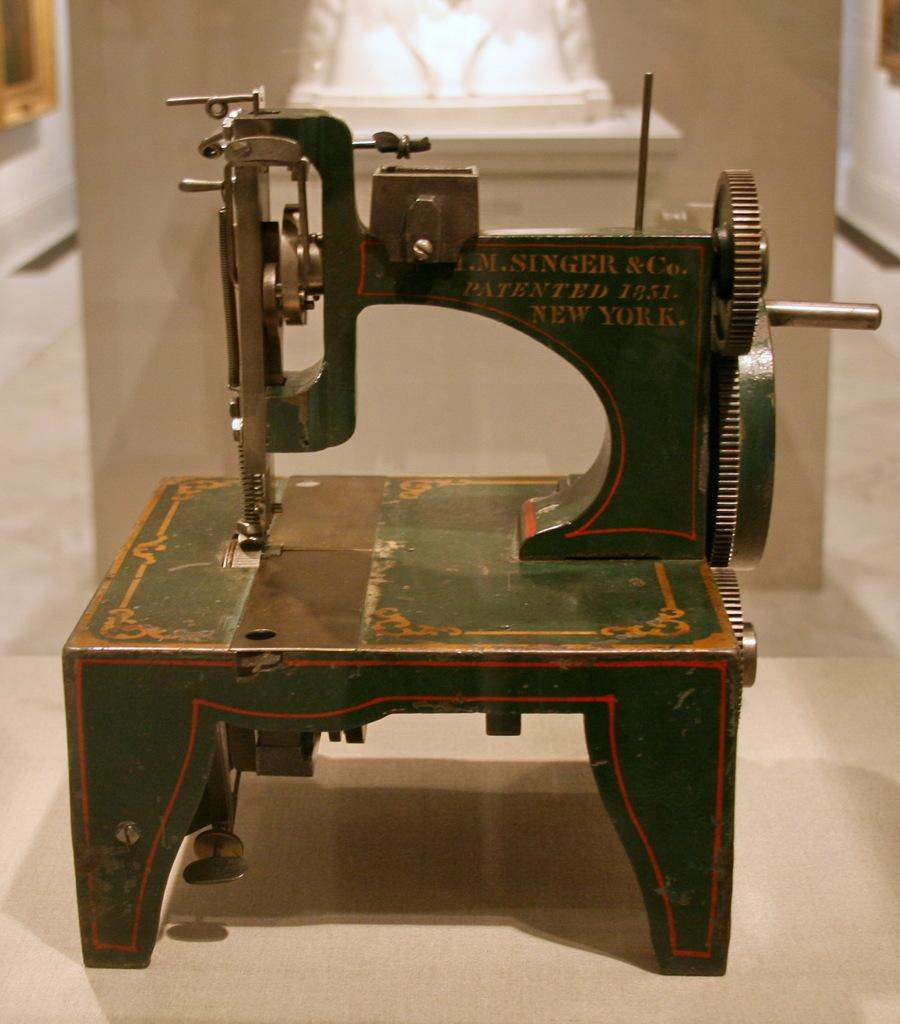What is the main object in the image? There is a tailoring machine in the image. Where is the tailoring machine located? The tailoring machine is placed on a table. What type of plantation can be seen in the background of the image? There is no plantation visible in the image; it only features a tailoring machine on a table. How many rings are present on the tailoring machine in the image? There are no rings present on the tailoring machine in the image. 